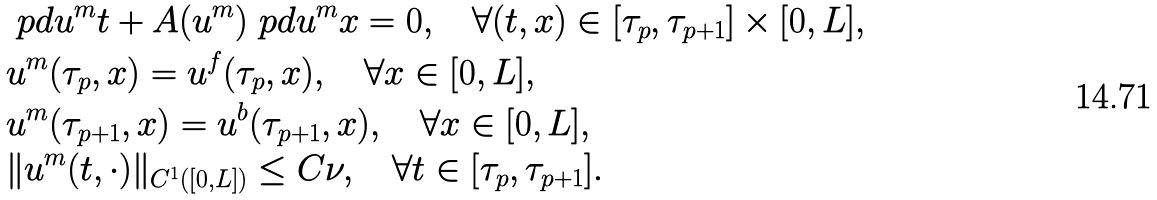<formula> <loc_0><loc_0><loc_500><loc_500>& \ p d { u ^ { m } } t + A ( u ^ { m } ) \ p d { u ^ { m } } x = 0 , \quad \forall ( t , x ) \in [ \tau _ { p } , \tau _ { p + 1 } ] \times [ 0 , L ] , \\ & u ^ { m } ( \tau _ { p } , x ) = u ^ { f } ( \tau _ { p } , x ) , \quad \forall x \in [ 0 , L ] , \\ & u ^ { m } ( \tau _ { p + 1 } , x ) = u ^ { b } ( \tau _ { p + 1 } , x ) , \quad \forall x \in [ 0 , L ] , \\ & \| u ^ { m } ( t , \cdot ) \| _ { C ^ { 1 } ( [ 0 , L ] ) } \leq C \nu , \quad \forall t \in [ \tau _ { p } , \tau _ { p + 1 } ] .</formula> 